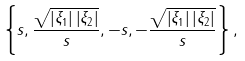<formula> <loc_0><loc_0><loc_500><loc_500>\left \{ s , \frac { \sqrt { \left | \xi _ { 1 } \right | \left | \xi _ { 2 } \right | } } { s } , - s , - \frac { \sqrt { \left | \xi _ { 1 } \right | \left | \xi _ { 2 } \right | } } { s } \right \} ,</formula> 